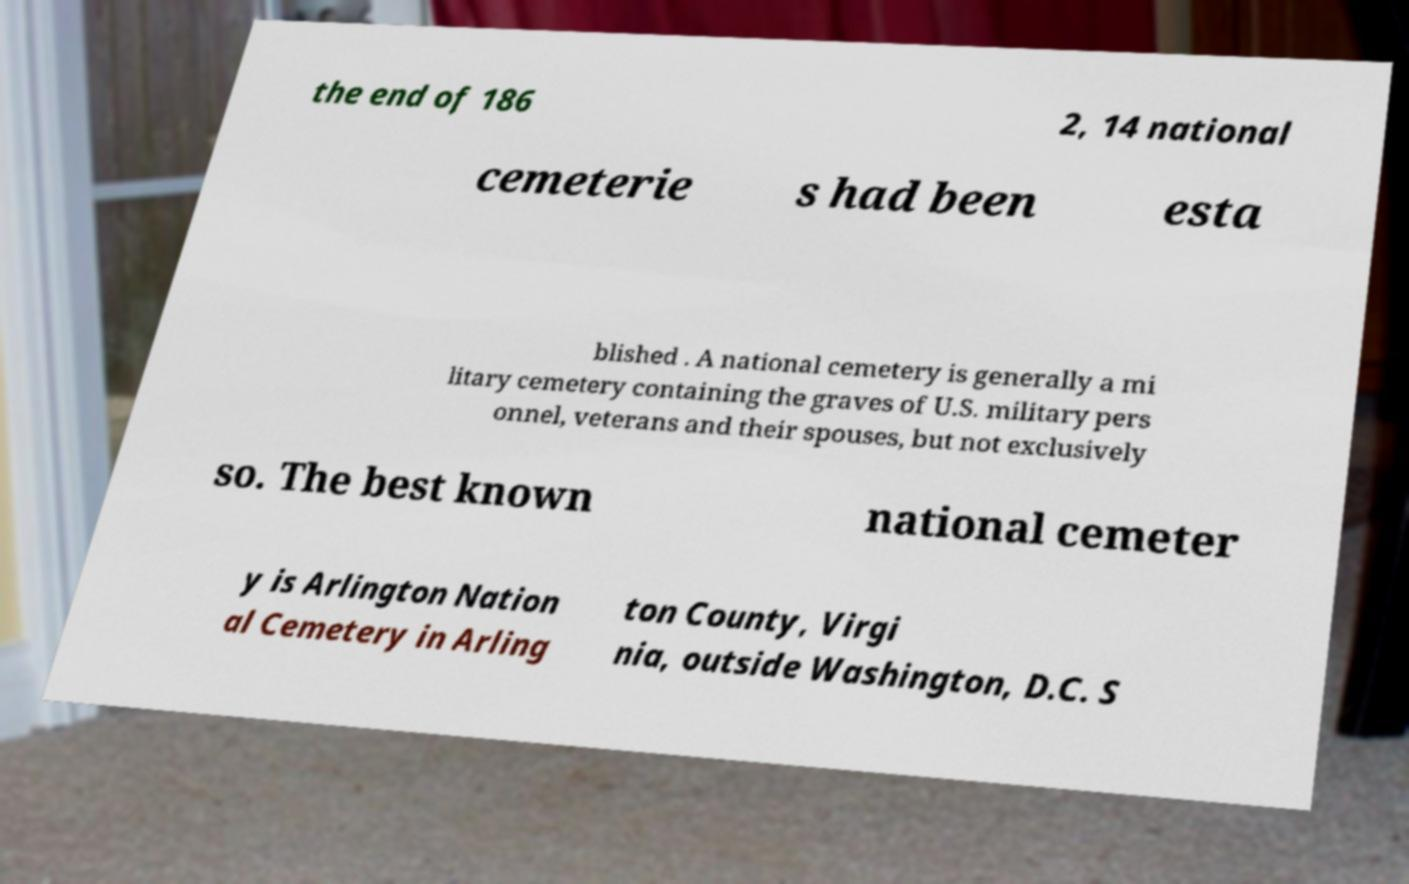What messages or text are displayed in this image? I need them in a readable, typed format. the end of 186 2, 14 national cemeterie s had been esta blished . A national cemetery is generally a mi litary cemetery containing the graves of U.S. military pers onnel, veterans and their spouses, but not exclusively so. The best known national cemeter y is Arlington Nation al Cemetery in Arling ton County, Virgi nia, outside Washington, D.C. S 